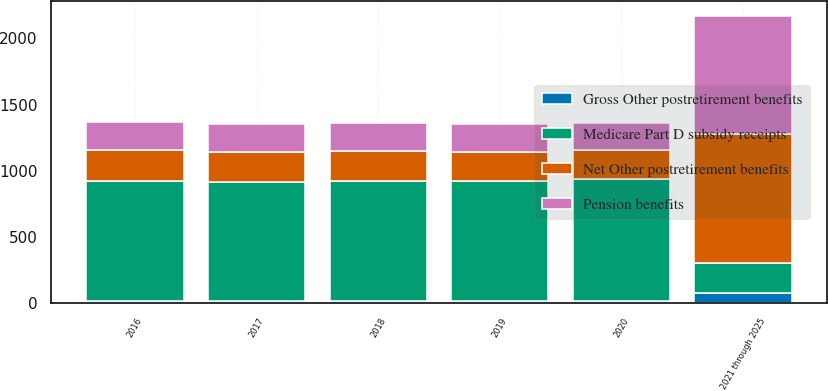<chart> <loc_0><loc_0><loc_500><loc_500><stacked_bar_chart><ecel><fcel>2016<fcel>2017<fcel>2018<fcel>2019<fcel>2020<fcel>2021 through 2025<nl><fcel>Medicare Part D subsidy receipts<fcel>910<fcel>900<fcel>910<fcel>910<fcel>920<fcel>220<nl><fcel>Net Other postretirement benefits<fcel>230<fcel>225<fcel>225<fcel>220<fcel>220<fcel>975<nl><fcel>Gross Other postretirement benefits<fcel>15<fcel>15<fcel>15<fcel>15<fcel>20<fcel>80<nl><fcel>Pension benefits<fcel>215<fcel>210<fcel>210<fcel>205<fcel>200<fcel>895<nl></chart> 